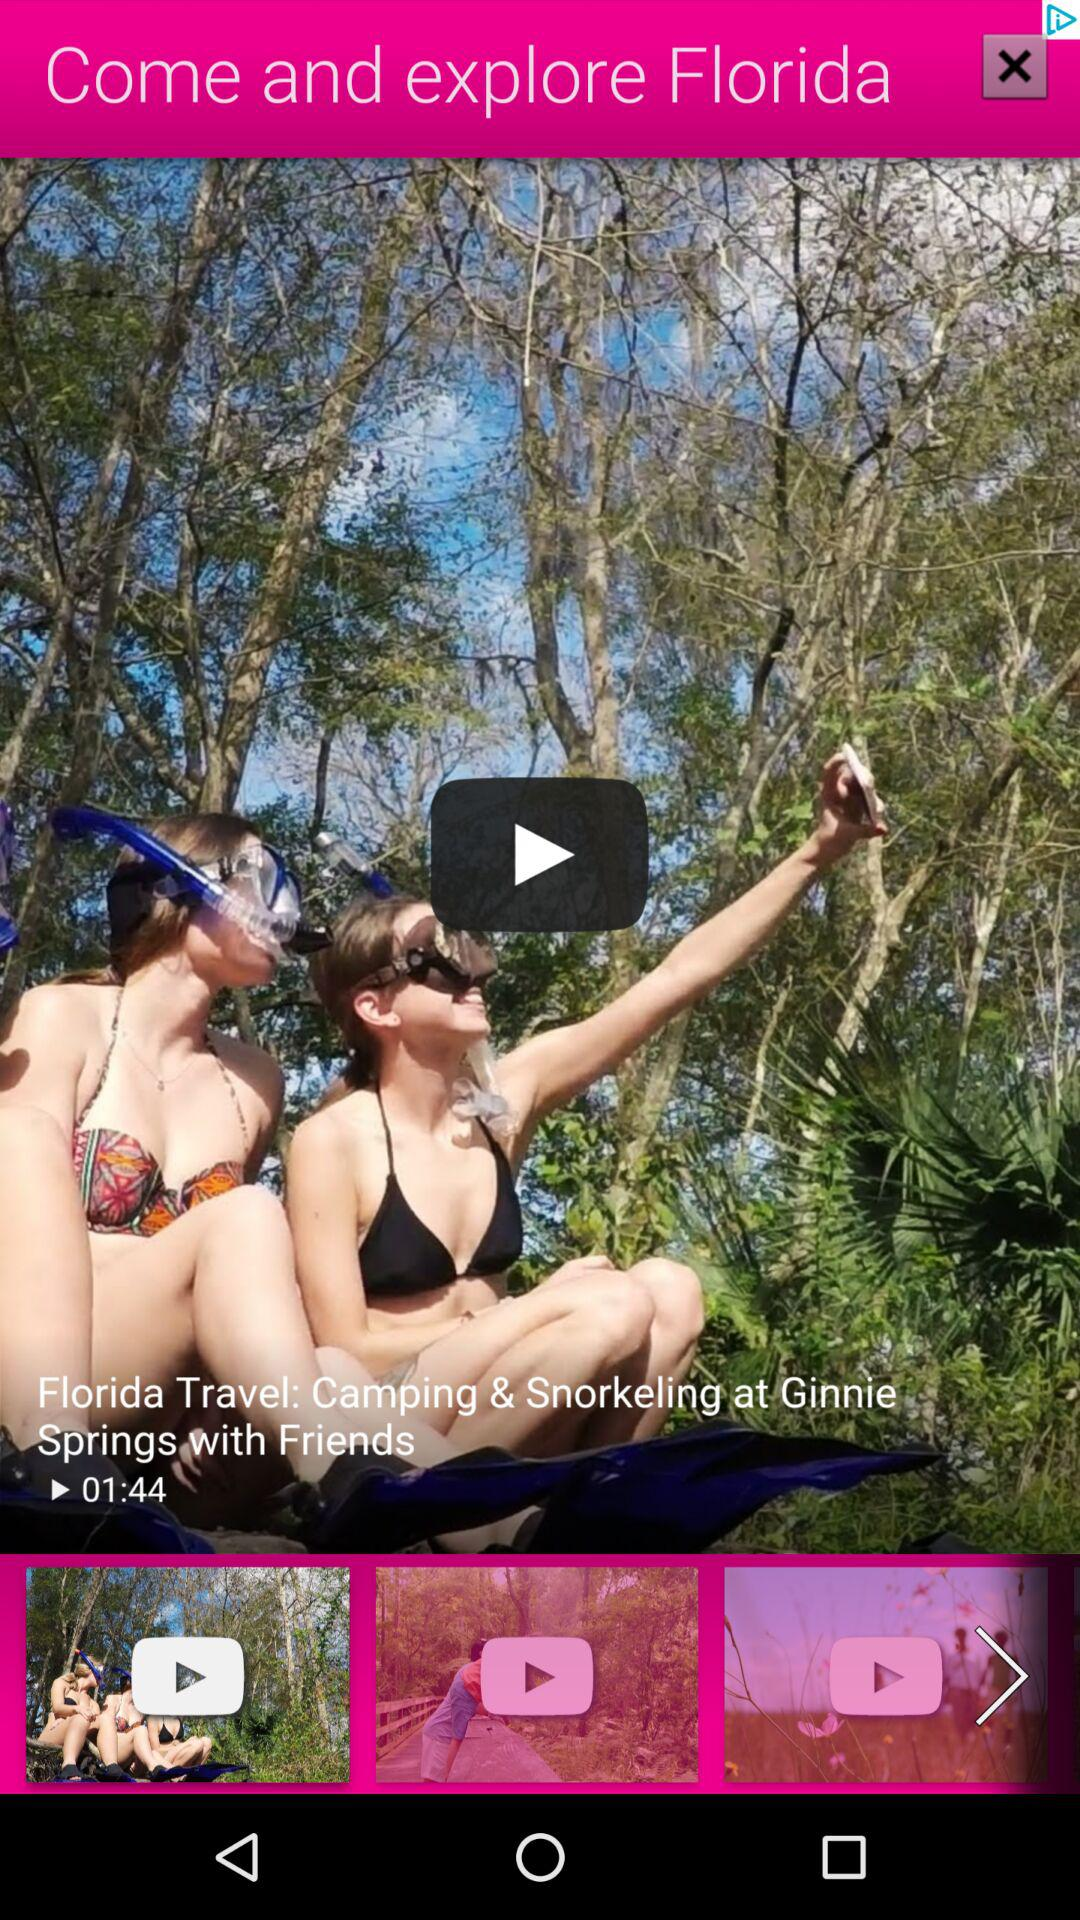How long is the duration of the second video?
When the provided information is insufficient, respond with <no answer>. <no answer> 